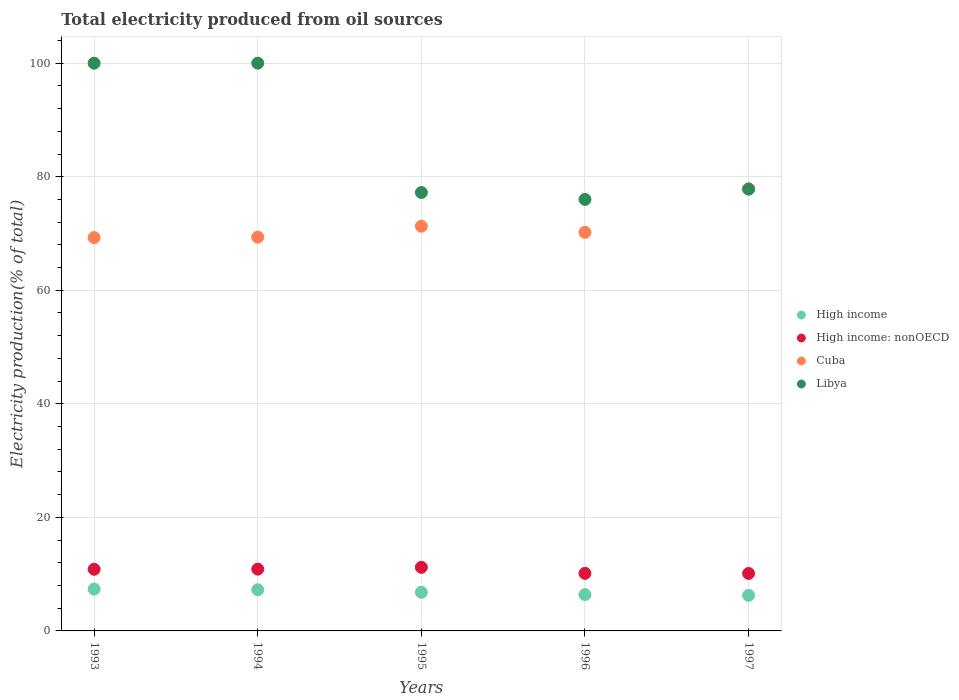Is the number of dotlines equal to the number of legend labels?
Your answer should be very brief. Yes. What is the total electricity produced in Cuba in 1993?
Provide a short and direct response. 69.29. Across all years, what is the maximum total electricity produced in Cuba?
Provide a short and direct response. 77.88. Across all years, what is the minimum total electricity produced in High income?
Ensure brevity in your answer.  6.28. In which year was the total electricity produced in High income maximum?
Give a very brief answer. 1993. What is the total total electricity produced in High income in the graph?
Provide a short and direct response. 34.1. What is the difference between the total electricity produced in High income in 1993 and the total electricity produced in Libya in 1996?
Keep it short and to the point. -68.64. What is the average total electricity produced in High income per year?
Your answer should be compact. 6.82. In the year 1993, what is the difference between the total electricity produced in Cuba and total electricity produced in High income: nonOECD?
Offer a very short reply. 58.43. In how many years, is the total electricity produced in High income: nonOECD greater than 20 %?
Give a very brief answer. 0. What is the ratio of the total electricity produced in Cuba in 1994 to that in 1995?
Your answer should be compact. 0.97. What is the difference between the highest and the second highest total electricity produced in Libya?
Make the answer very short. 0. What is the difference between the highest and the lowest total electricity produced in Cuba?
Provide a short and direct response. 8.59. In how many years, is the total electricity produced in High income greater than the average total electricity produced in High income taken over all years?
Your answer should be very brief. 2. How many years are there in the graph?
Your answer should be compact. 5. How are the legend labels stacked?
Your response must be concise. Vertical. What is the title of the graph?
Give a very brief answer. Total electricity produced from oil sources. Does "St. Lucia" appear as one of the legend labels in the graph?
Ensure brevity in your answer.  No. What is the label or title of the Y-axis?
Provide a succinct answer. Electricity production(% of total). What is the Electricity production(% of total) of High income in 1993?
Ensure brevity in your answer.  7.37. What is the Electricity production(% of total) in High income: nonOECD in 1993?
Offer a terse response. 10.86. What is the Electricity production(% of total) of Cuba in 1993?
Your answer should be compact. 69.29. What is the Electricity production(% of total) of Libya in 1993?
Your response must be concise. 100. What is the Electricity production(% of total) in High income in 1994?
Your answer should be compact. 7.25. What is the Electricity production(% of total) in High income: nonOECD in 1994?
Offer a very short reply. 10.88. What is the Electricity production(% of total) of Cuba in 1994?
Give a very brief answer. 69.35. What is the Electricity production(% of total) in Libya in 1994?
Provide a succinct answer. 100. What is the Electricity production(% of total) of High income in 1995?
Make the answer very short. 6.8. What is the Electricity production(% of total) of High income: nonOECD in 1995?
Offer a terse response. 11.2. What is the Electricity production(% of total) in Cuba in 1995?
Provide a succinct answer. 71.28. What is the Electricity production(% of total) in Libya in 1995?
Your answer should be compact. 77.22. What is the Electricity production(% of total) in High income in 1996?
Give a very brief answer. 6.4. What is the Electricity production(% of total) of High income: nonOECD in 1996?
Your response must be concise. 10.14. What is the Electricity production(% of total) of Cuba in 1996?
Give a very brief answer. 70.2. What is the Electricity production(% of total) of Libya in 1996?
Ensure brevity in your answer.  76.01. What is the Electricity production(% of total) of High income in 1997?
Give a very brief answer. 6.28. What is the Electricity production(% of total) in High income: nonOECD in 1997?
Your response must be concise. 10.12. What is the Electricity production(% of total) of Cuba in 1997?
Provide a succinct answer. 77.88. What is the Electricity production(% of total) of Libya in 1997?
Keep it short and to the point. 77.81. Across all years, what is the maximum Electricity production(% of total) of High income?
Provide a short and direct response. 7.37. Across all years, what is the maximum Electricity production(% of total) in High income: nonOECD?
Provide a succinct answer. 11.2. Across all years, what is the maximum Electricity production(% of total) in Cuba?
Keep it short and to the point. 77.88. Across all years, what is the minimum Electricity production(% of total) in High income?
Your answer should be very brief. 6.28. Across all years, what is the minimum Electricity production(% of total) in High income: nonOECD?
Provide a succinct answer. 10.12. Across all years, what is the minimum Electricity production(% of total) in Cuba?
Your answer should be compact. 69.29. Across all years, what is the minimum Electricity production(% of total) of Libya?
Your answer should be very brief. 76.01. What is the total Electricity production(% of total) of High income in the graph?
Ensure brevity in your answer.  34.1. What is the total Electricity production(% of total) in High income: nonOECD in the graph?
Your response must be concise. 53.21. What is the total Electricity production(% of total) of Cuba in the graph?
Offer a terse response. 358. What is the total Electricity production(% of total) of Libya in the graph?
Give a very brief answer. 431.04. What is the difference between the Electricity production(% of total) of High income in 1993 and that in 1994?
Make the answer very short. 0.11. What is the difference between the Electricity production(% of total) in High income: nonOECD in 1993 and that in 1994?
Your answer should be very brief. -0.02. What is the difference between the Electricity production(% of total) in Cuba in 1993 and that in 1994?
Keep it short and to the point. -0.06. What is the difference between the Electricity production(% of total) of Libya in 1993 and that in 1994?
Provide a short and direct response. 0. What is the difference between the Electricity production(% of total) in High income in 1993 and that in 1995?
Keep it short and to the point. 0.57. What is the difference between the Electricity production(% of total) of High income: nonOECD in 1993 and that in 1995?
Your response must be concise. -0.34. What is the difference between the Electricity production(% of total) of Cuba in 1993 and that in 1995?
Your answer should be compact. -1.99. What is the difference between the Electricity production(% of total) of Libya in 1993 and that in 1995?
Offer a very short reply. 22.78. What is the difference between the Electricity production(% of total) in High income in 1993 and that in 1996?
Keep it short and to the point. 0.97. What is the difference between the Electricity production(% of total) in High income: nonOECD in 1993 and that in 1996?
Make the answer very short. 0.72. What is the difference between the Electricity production(% of total) of Cuba in 1993 and that in 1996?
Give a very brief answer. -0.92. What is the difference between the Electricity production(% of total) of Libya in 1993 and that in 1996?
Ensure brevity in your answer.  23.99. What is the difference between the Electricity production(% of total) in High income in 1993 and that in 1997?
Keep it short and to the point. 1.09. What is the difference between the Electricity production(% of total) of High income: nonOECD in 1993 and that in 1997?
Provide a succinct answer. 0.73. What is the difference between the Electricity production(% of total) of Cuba in 1993 and that in 1997?
Offer a very short reply. -8.59. What is the difference between the Electricity production(% of total) of Libya in 1993 and that in 1997?
Keep it short and to the point. 22.19. What is the difference between the Electricity production(% of total) in High income in 1994 and that in 1995?
Your answer should be very brief. 0.45. What is the difference between the Electricity production(% of total) of High income: nonOECD in 1994 and that in 1995?
Provide a succinct answer. -0.32. What is the difference between the Electricity production(% of total) in Cuba in 1994 and that in 1995?
Your answer should be very brief. -1.93. What is the difference between the Electricity production(% of total) of Libya in 1994 and that in 1995?
Ensure brevity in your answer.  22.78. What is the difference between the Electricity production(% of total) of High income in 1994 and that in 1996?
Offer a terse response. 0.85. What is the difference between the Electricity production(% of total) of High income: nonOECD in 1994 and that in 1996?
Give a very brief answer. 0.74. What is the difference between the Electricity production(% of total) of Cuba in 1994 and that in 1996?
Provide a short and direct response. -0.85. What is the difference between the Electricity production(% of total) in Libya in 1994 and that in 1996?
Provide a succinct answer. 23.99. What is the difference between the Electricity production(% of total) of High income in 1994 and that in 1997?
Give a very brief answer. 0.98. What is the difference between the Electricity production(% of total) of High income: nonOECD in 1994 and that in 1997?
Give a very brief answer. 0.76. What is the difference between the Electricity production(% of total) of Cuba in 1994 and that in 1997?
Keep it short and to the point. -8.53. What is the difference between the Electricity production(% of total) in Libya in 1994 and that in 1997?
Keep it short and to the point. 22.19. What is the difference between the Electricity production(% of total) of High income in 1995 and that in 1996?
Ensure brevity in your answer.  0.4. What is the difference between the Electricity production(% of total) of High income: nonOECD in 1995 and that in 1996?
Ensure brevity in your answer.  1.06. What is the difference between the Electricity production(% of total) in Cuba in 1995 and that in 1996?
Give a very brief answer. 1.08. What is the difference between the Electricity production(% of total) of Libya in 1995 and that in 1996?
Your answer should be compact. 1.22. What is the difference between the Electricity production(% of total) in High income in 1995 and that in 1997?
Provide a succinct answer. 0.53. What is the difference between the Electricity production(% of total) of High income: nonOECD in 1995 and that in 1997?
Offer a terse response. 1.08. What is the difference between the Electricity production(% of total) of Cuba in 1995 and that in 1997?
Provide a succinct answer. -6.6. What is the difference between the Electricity production(% of total) of Libya in 1995 and that in 1997?
Provide a succinct answer. -0.59. What is the difference between the Electricity production(% of total) of High income in 1996 and that in 1997?
Offer a very short reply. 0.13. What is the difference between the Electricity production(% of total) in High income: nonOECD in 1996 and that in 1997?
Your answer should be very brief. 0.02. What is the difference between the Electricity production(% of total) of Cuba in 1996 and that in 1997?
Keep it short and to the point. -7.68. What is the difference between the Electricity production(% of total) in Libya in 1996 and that in 1997?
Keep it short and to the point. -1.81. What is the difference between the Electricity production(% of total) in High income in 1993 and the Electricity production(% of total) in High income: nonOECD in 1994?
Offer a very short reply. -3.52. What is the difference between the Electricity production(% of total) in High income in 1993 and the Electricity production(% of total) in Cuba in 1994?
Your answer should be very brief. -61.98. What is the difference between the Electricity production(% of total) in High income in 1993 and the Electricity production(% of total) in Libya in 1994?
Provide a short and direct response. -92.63. What is the difference between the Electricity production(% of total) in High income: nonOECD in 1993 and the Electricity production(% of total) in Cuba in 1994?
Your answer should be very brief. -58.49. What is the difference between the Electricity production(% of total) in High income: nonOECD in 1993 and the Electricity production(% of total) in Libya in 1994?
Keep it short and to the point. -89.14. What is the difference between the Electricity production(% of total) in Cuba in 1993 and the Electricity production(% of total) in Libya in 1994?
Give a very brief answer. -30.71. What is the difference between the Electricity production(% of total) in High income in 1993 and the Electricity production(% of total) in High income: nonOECD in 1995?
Ensure brevity in your answer.  -3.83. What is the difference between the Electricity production(% of total) in High income in 1993 and the Electricity production(% of total) in Cuba in 1995?
Keep it short and to the point. -63.91. What is the difference between the Electricity production(% of total) in High income in 1993 and the Electricity production(% of total) in Libya in 1995?
Offer a very short reply. -69.86. What is the difference between the Electricity production(% of total) in High income: nonOECD in 1993 and the Electricity production(% of total) in Cuba in 1995?
Provide a succinct answer. -60.42. What is the difference between the Electricity production(% of total) of High income: nonOECD in 1993 and the Electricity production(% of total) of Libya in 1995?
Offer a very short reply. -66.36. What is the difference between the Electricity production(% of total) of Cuba in 1993 and the Electricity production(% of total) of Libya in 1995?
Your answer should be compact. -7.94. What is the difference between the Electricity production(% of total) in High income in 1993 and the Electricity production(% of total) in High income: nonOECD in 1996?
Your answer should be compact. -2.77. What is the difference between the Electricity production(% of total) of High income in 1993 and the Electricity production(% of total) of Cuba in 1996?
Offer a terse response. -62.83. What is the difference between the Electricity production(% of total) in High income in 1993 and the Electricity production(% of total) in Libya in 1996?
Your answer should be very brief. -68.64. What is the difference between the Electricity production(% of total) in High income: nonOECD in 1993 and the Electricity production(% of total) in Cuba in 1996?
Provide a short and direct response. -59.34. What is the difference between the Electricity production(% of total) in High income: nonOECD in 1993 and the Electricity production(% of total) in Libya in 1996?
Ensure brevity in your answer.  -65.15. What is the difference between the Electricity production(% of total) in Cuba in 1993 and the Electricity production(% of total) in Libya in 1996?
Provide a short and direct response. -6.72. What is the difference between the Electricity production(% of total) in High income in 1993 and the Electricity production(% of total) in High income: nonOECD in 1997?
Make the answer very short. -2.76. What is the difference between the Electricity production(% of total) in High income in 1993 and the Electricity production(% of total) in Cuba in 1997?
Your response must be concise. -70.51. What is the difference between the Electricity production(% of total) of High income in 1993 and the Electricity production(% of total) of Libya in 1997?
Your answer should be compact. -70.45. What is the difference between the Electricity production(% of total) in High income: nonOECD in 1993 and the Electricity production(% of total) in Cuba in 1997?
Keep it short and to the point. -67.02. What is the difference between the Electricity production(% of total) of High income: nonOECD in 1993 and the Electricity production(% of total) of Libya in 1997?
Give a very brief answer. -66.95. What is the difference between the Electricity production(% of total) in Cuba in 1993 and the Electricity production(% of total) in Libya in 1997?
Offer a terse response. -8.53. What is the difference between the Electricity production(% of total) in High income in 1994 and the Electricity production(% of total) in High income: nonOECD in 1995?
Give a very brief answer. -3.95. What is the difference between the Electricity production(% of total) of High income in 1994 and the Electricity production(% of total) of Cuba in 1995?
Offer a terse response. -64.03. What is the difference between the Electricity production(% of total) in High income in 1994 and the Electricity production(% of total) in Libya in 1995?
Keep it short and to the point. -69.97. What is the difference between the Electricity production(% of total) in High income: nonOECD in 1994 and the Electricity production(% of total) in Cuba in 1995?
Your answer should be very brief. -60.4. What is the difference between the Electricity production(% of total) of High income: nonOECD in 1994 and the Electricity production(% of total) of Libya in 1995?
Offer a very short reply. -66.34. What is the difference between the Electricity production(% of total) in Cuba in 1994 and the Electricity production(% of total) in Libya in 1995?
Your answer should be very brief. -7.87. What is the difference between the Electricity production(% of total) of High income in 1994 and the Electricity production(% of total) of High income: nonOECD in 1996?
Offer a terse response. -2.89. What is the difference between the Electricity production(% of total) in High income in 1994 and the Electricity production(% of total) in Cuba in 1996?
Make the answer very short. -62.95. What is the difference between the Electricity production(% of total) in High income in 1994 and the Electricity production(% of total) in Libya in 1996?
Your response must be concise. -68.75. What is the difference between the Electricity production(% of total) of High income: nonOECD in 1994 and the Electricity production(% of total) of Cuba in 1996?
Make the answer very short. -59.32. What is the difference between the Electricity production(% of total) of High income: nonOECD in 1994 and the Electricity production(% of total) of Libya in 1996?
Your answer should be compact. -65.12. What is the difference between the Electricity production(% of total) in Cuba in 1994 and the Electricity production(% of total) in Libya in 1996?
Your answer should be very brief. -6.65. What is the difference between the Electricity production(% of total) of High income in 1994 and the Electricity production(% of total) of High income: nonOECD in 1997?
Offer a very short reply. -2.87. What is the difference between the Electricity production(% of total) of High income in 1994 and the Electricity production(% of total) of Cuba in 1997?
Your answer should be very brief. -70.63. What is the difference between the Electricity production(% of total) of High income in 1994 and the Electricity production(% of total) of Libya in 1997?
Your response must be concise. -70.56. What is the difference between the Electricity production(% of total) in High income: nonOECD in 1994 and the Electricity production(% of total) in Cuba in 1997?
Give a very brief answer. -67. What is the difference between the Electricity production(% of total) in High income: nonOECD in 1994 and the Electricity production(% of total) in Libya in 1997?
Ensure brevity in your answer.  -66.93. What is the difference between the Electricity production(% of total) in Cuba in 1994 and the Electricity production(% of total) in Libya in 1997?
Your answer should be compact. -8.46. What is the difference between the Electricity production(% of total) in High income in 1995 and the Electricity production(% of total) in High income: nonOECD in 1996?
Your response must be concise. -3.34. What is the difference between the Electricity production(% of total) of High income in 1995 and the Electricity production(% of total) of Cuba in 1996?
Your answer should be compact. -63.4. What is the difference between the Electricity production(% of total) of High income in 1995 and the Electricity production(% of total) of Libya in 1996?
Offer a very short reply. -69.2. What is the difference between the Electricity production(% of total) in High income: nonOECD in 1995 and the Electricity production(% of total) in Cuba in 1996?
Provide a short and direct response. -59. What is the difference between the Electricity production(% of total) of High income: nonOECD in 1995 and the Electricity production(% of total) of Libya in 1996?
Give a very brief answer. -64.8. What is the difference between the Electricity production(% of total) in Cuba in 1995 and the Electricity production(% of total) in Libya in 1996?
Ensure brevity in your answer.  -4.72. What is the difference between the Electricity production(% of total) of High income in 1995 and the Electricity production(% of total) of High income: nonOECD in 1997?
Your answer should be very brief. -3.32. What is the difference between the Electricity production(% of total) in High income in 1995 and the Electricity production(% of total) in Cuba in 1997?
Give a very brief answer. -71.08. What is the difference between the Electricity production(% of total) in High income in 1995 and the Electricity production(% of total) in Libya in 1997?
Ensure brevity in your answer.  -71.01. What is the difference between the Electricity production(% of total) of High income: nonOECD in 1995 and the Electricity production(% of total) of Cuba in 1997?
Provide a succinct answer. -66.68. What is the difference between the Electricity production(% of total) in High income: nonOECD in 1995 and the Electricity production(% of total) in Libya in 1997?
Ensure brevity in your answer.  -66.61. What is the difference between the Electricity production(% of total) in Cuba in 1995 and the Electricity production(% of total) in Libya in 1997?
Your answer should be compact. -6.53. What is the difference between the Electricity production(% of total) in High income in 1996 and the Electricity production(% of total) in High income: nonOECD in 1997?
Provide a succinct answer. -3.72. What is the difference between the Electricity production(% of total) of High income in 1996 and the Electricity production(% of total) of Cuba in 1997?
Give a very brief answer. -71.48. What is the difference between the Electricity production(% of total) in High income in 1996 and the Electricity production(% of total) in Libya in 1997?
Provide a succinct answer. -71.41. What is the difference between the Electricity production(% of total) of High income: nonOECD in 1996 and the Electricity production(% of total) of Cuba in 1997?
Your answer should be very brief. -67.74. What is the difference between the Electricity production(% of total) in High income: nonOECD in 1996 and the Electricity production(% of total) in Libya in 1997?
Your answer should be compact. -67.67. What is the difference between the Electricity production(% of total) of Cuba in 1996 and the Electricity production(% of total) of Libya in 1997?
Your response must be concise. -7.61. What is the average Electricity production(% of total) of High income per year?
Give a very brief answer. 6.82. What is the average Electricity production(% of total) in High income: nonOECD per year?
Your answer should be compact. 10.64. What is the average Electricity production(% of total) of Cuba per year?
Offer a terse response. 71.6. What is the average Electricity production(% of total) in Libya per year?
Ensure brevity in your answer.  86.21. In the year 1993, what is the difference between the Electricity production(% of total) of High income and Electricity production(% of total) of High income: nonOECD?
Keep it short and to the point. -3.49. In the year 1993, what is the difference between the Electricity production(% of total) in High income and Electricity production(% of total) in Cuba?
Provide a short and direct response. -61.92. In the year 1993, what is the difference between the Electricity production(% of total) of High income and Electricity production(% of total) of Libya?
Offer a very short reply. -92.63. In the year 1993, what is the difference between the Electricity production(% of total) in High income: nonOECD and Electricity production(% of total) in Cuba?
Make the answer very short. -58.43. In the year 1993, what is the difference between the Electricity production(% of total) of High income: nonOECD and Electricity production(% of total) of Libya?
Your answer should be very brief. -89.14. In the year 1993, what is the difference between the Electricity production(% of total) in Cuba and Electricity production(% of total) in Libya?
Your answer should be compact. -30.71. In the year 1994, what is the difference between the Electricity production(% of total) in High income and Electricity production(% of total) in High income: nonOECD?
Give a very brief answer. -3.63. In the year 1994, what is the difference between the Electricity production(% of total) of High income and Electricity production(% of total) of Cuba?
Your response must be concise. -62.1. In the year 1994, what is the difference between the Electricity production(% of total) in High income and Electricity production(% of total) in Libya?
Give a very brief answer. -92.75. In the year 1994, what is the difference between the Electricity production(% of total) of High income: nonOECD and Electricity production(% of total) of Cuba?
Provide a short and direct response. -58.47. In the year 1994, what is the difference between the Electricity production(% of total) of High income: nonOECD and Electricity production(% of total) of Libya?
Your answer should be very brief. -89.12. In the year 1994, what is the difference between the Electricity production(% of total) of Cuba and Electricity production(% of total) of Libya?
Offer a terse response. -30.65. In the year 1995, what is the difference between the Electricity production(% of total) of High income and Electricity production(% of total) of High income: nonOECD?
Offer a very short reply. -4.4. In the year 1995, what is the difference between the Electricity production(% of total) in High income and Electricity production(% of total) in Cuba?
Make the answer very short. -64.48. In the year 1995, what is the difference between the Electricity production(% of total) in High income and Electricity production(% of total) in Libya?
Give a very brief answer. -70.42. In the year 1995, what is the difference between the Electricity production(% of total) in High income: nonOECD and Electricity production(% of total) in Cuba?
Offer a terse response. -60.08. In the year 1995, what is the difference between the Electricity production(% of total) in High income: nonOECD and Electricity production(% of total) in Libya?
Make the answer very short. -66.02. In the year 1995, what is the difference between the Electricity production(% of total) of Cuba and Electricity production(% of total) of Libya?
Make the answer very short. -5.94. In the year 1996, what is the difference between the Electricity production(% of total) of High income and Electricity production(% of total) of High income: nonOECD?
Your response must be concise. -3.74. In the year 1996, what is the difference between the Electricity production(% of total) in High income and Electricity production(% of total) in Cuba?
Make the answer very short. -63.8. In the year 1996, what is the difference between the Electricity production(% of total) in High income and Electricity production(% of total) in Libya?
Your answer should be very brief. -69.6. In the year 1996, what is the difference between the Electricity production(% of total) in High income: nonOECD and Electricity production(% of total) in Cuba?
Your answer should be compact. -60.06. In the year 1996, what is the difference between the Electricity production(% of total) in High income: nonOECD and Electricity production(% of total) in Libya?
Your answer should be very brief. -65.87. In the year 1996, what is the difference between the Electricity production(% of total) in Cuba and Electricity production(% of total) in Libya?
Ensure brevity in your answer.  -5.8. In the year 1997, what is the difference between the Electricity production(% of total) in High income and Electricity production(% of total) in High income: nonOECD?
Your answer should be compact. -3.85. In the year 1997, what is the difference between the Electricity production(% of total) in High income and Electricity production(% of total) in Cuba?
Give a very brief answer. -71.6. In the year 1997, what is the difference between the Electricity production(% of total) in High income and Electricity production(% of total) in Libya?
Your answer should be compact. -71.54. In the year 1997, what is the difference between the Electricity production(% of total) of High income: nonOECD and Electricity production(% of total) of Cuba?
Provide a succinct answer. -67.76. In the year 1997, what is the difference between the Electricity production(% of total) of High income: nonOECD and Electricity production(% of total) of Libya?
Offer a terse response. -67.69. In the year 1997, what is the difference between the Electricity production(% of total) of Cuba and Electricity production(% of total) of Libya?
Make the answer very short. 0.07. What is the ratio of the Electricity production(% of total) in High income in 1993 to that in 1994?
Offer a terse response. 1.02. What is the ratio of the Electricity production(% of total) of Cuba in 1993 to that in 1994?
Your answer should be compact. 1. What is the ratio of the Electricity production(% of total) in High income in 1993 to that in 1995?
Provide a succinct answer. 1.08. What is the ratio of the Electricity production(% of total) in High income: nonOECD in 1993 to that in 1995?
Offer a very short reply. 0.97. What is the ratio of the Electricity production(% of total) in Libya in 1993 to that in 1995?
Provide a succinct answer. 1.29. What is the ratio of the Electricity production(% of total) in High income in 1993 to that in 1996?
Your response must be concise. 1.15. What is the ratio of the Electricity production(% of total) in High income: nonOECD in 1993 to that in 1996?
Offer a very short reply. 1.07. What is the ratio of the Electricity production(% of total) in Libya in 1993 to that in 1996?
Offer a very short reply. 1.32. What is the ratio of the Electricity production(% of total) in High income in 1993 to that in 1997?
Offer a very short reply. 1.17. What is the ratio of the Electricity production(% of total) in High income: nonOECD in 1993 to that in 1997?
Offer a very short reply. 1.07. What is the ratio of the Electricity production(% of total) in Cuba in 1993 to that in 1997?
Your answer should be compact. 0.89. What is the ratio of the Electricity production(% of total) of Libya in 1993 to that in 1997?
Your response must be concise. 1.29. What is the ratio of the Electricity production(% of total) in High income in 1994 to that in 1995?
Your answer should be compact. 1.07. What is the ratio of the Electricity production(% of total) in High income: nonOECD in 1994 to that in 1995?
Your answer should be very brief. 0.97. What is the ratio of the Electricity production(% of total) of Cuba in 1994 to that in 1995?
Your answer should be very brief. 0.97. What is the ratio of the Electricity production(% of total) in Libya in 1994 to that in 1995?
Make the answer very short. 1.29. What is the ratio of the Electricity production(% of total) in High income in 1994 to that in 1996?
Offer a terse response. 1.13. What is the ratio of the Electricity production(% of total) of High income: nonOECD in 1994 to that in 1996?
Your answer should be compact. 1.07. What is the ratio of the Electricity production(% of total) of Cuba in 1994 to that in 1996?
Offer a terse response. 0.99. What is the ratio of the Electricity production(% of total) of Libya in 1994 to that in 1996?
Your response must be concise. 1.32. What is the ratio of the Electricity production(% of total) of High income in 1994 to that in 1997?
Ensure brevity in your answer.  1.16. What is the ratio of the Electricity production(% of total) of High income: nonOECD in 1994 to that in 1997?
Offer a terse response. 1.07. What is the ratio of the Electricity production(% of total) of Cuba in 1994 to that in 1997?
Your answer should be very brief. 0.89. What is the ratio of the Electricity production(% of total) in Libya in 1994 to that in 1997?
Give a very brief answer. 1.29. What is the ratio of the Electricity production(% of total) of High income in 1995 to that in 1996?
Provide a succinct answer. 1.06. What is the ratio of the Electricity production(% of total) in High income: nonOECD in 1995 to that in 1996?
Your answer should be compact. 1.1. What is the ratio of the Electricity production(% of total) in Cuba in 1995 to that in 1996?
Keep it short and to the point. 1.02. What is the ratio of the Electricity production(% of total) in High income in 1995 to that in 1997?
Your answer should be very brief. 1.08. What is the ratio of the Electricity production(% of total) of High income: nonOECD in 1995 to that in 1997?
Keep it short and to the point. 1.11. What is the ratio of the Electricity production(% of total) in Cuba in 1995 to that in 1997?
Your response must be concise. 0.92. What is the ratio of the Electricity production(% of total) in Libya in 1995 to that in 1997?
Give a very brief answer. 0.99. What is the ratio of the Electricity production(% of total) of High income in 1996 to that in 1997?
Provide a short and direct response. 1.02. What is the ratio of the Electricity production(% of total) of High income: nonOECD in 1996 to that in 1997?
Provide a short and direct response. 1. What is the ratio of the Electricity production(% of total) of Cuba in 1996 to that in 1997?
Provide a succinct answer. 0.9. What is the ratio of the Electricity production(% of total) in Libya in 1996 to that in 1997?
Provide a short and direct response. 0.98. What is the difference between the highest and the second highest Electricity production(% of total) in High income?
Make the answer very short. 0.11. What is the difference between the highest and the second highest Electricity production(% of total) of High income: nonOECD?
Offer a very short reply. 0.32. What is the difference between the highest and the second highest Electricity production(% of total) of Cuba?
Keep it short and to the point. 6.6. What is the difference between the highest and the lowest Electricity production(% of total) in High income?
Your answer should be compact. 1.09. What is the difference between the highest and the lowest Electricity production(% of total) in High income: nonOECD?
Make the answer very short. 1.08. What is the difference between the highest and the lowest Electricity production(% of total) of Cuba?
Your answer should be very brief. 8.59. What is the difference between the highest and the lowest Electricity production(% of total) in Libya?
Offer a terse response. 23.99. 